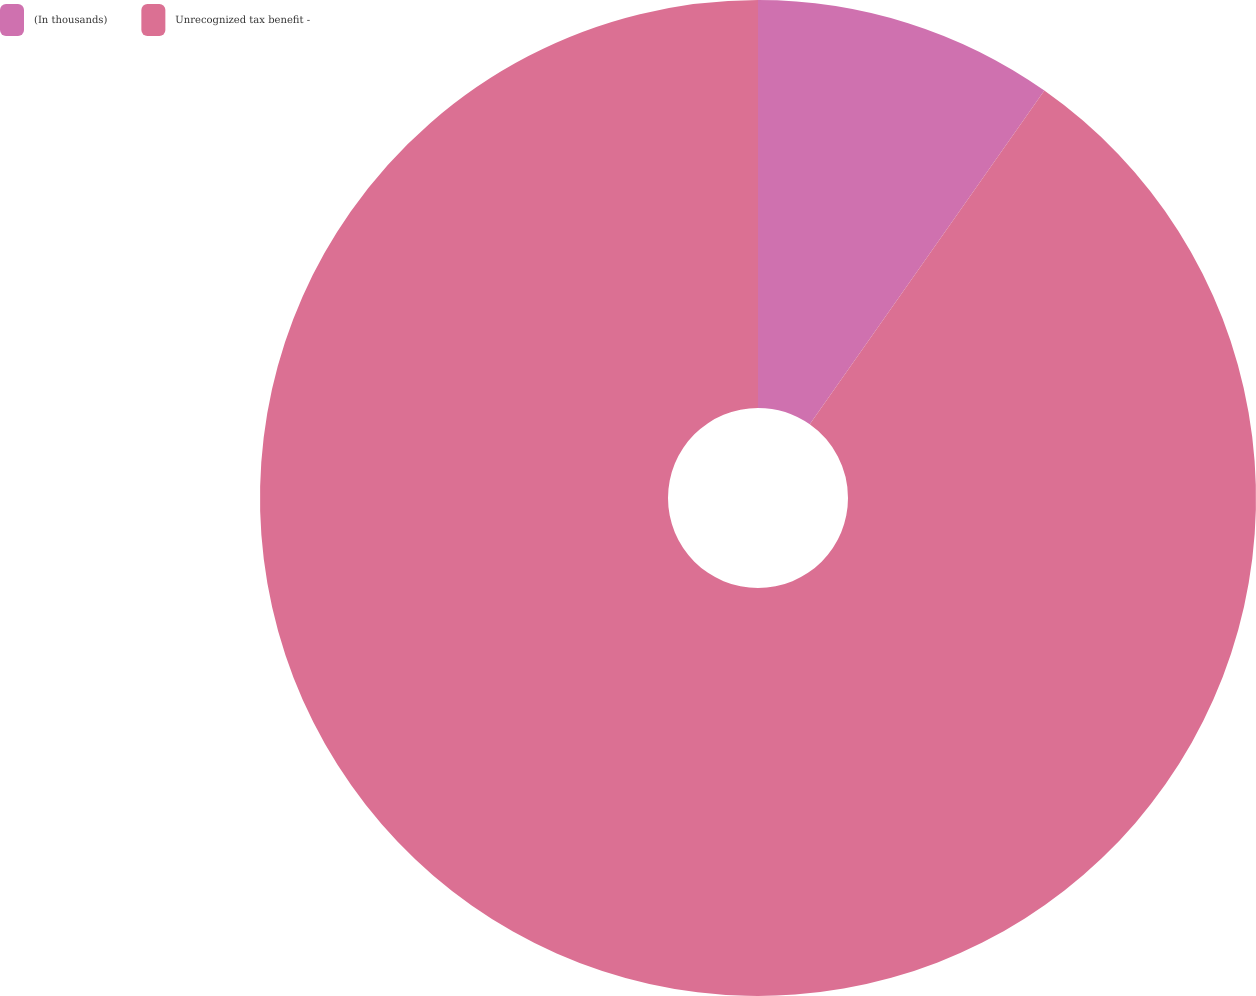Convert chart. <chart><loc_0><loc_0><loc_500><loc_500><pie_chart><fcel>(In thousands)<fcel>Unrecognized tax benefit -<nl><fcel>9.75%<fcel>90.25%<nl></chart> 